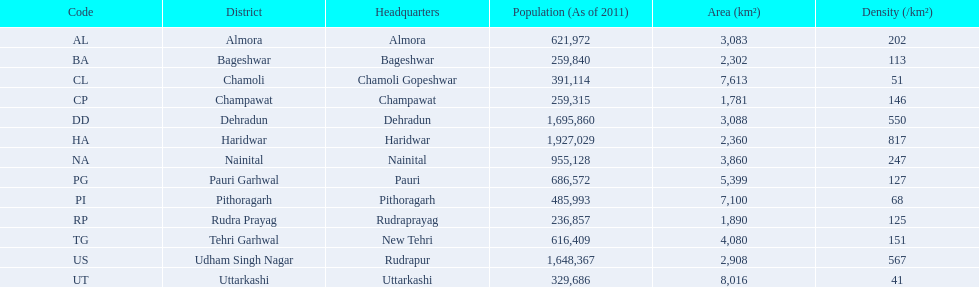What are the titles of all the districts? Almora, Bageshwar, Chamoli, Champawat, Dehradun, Haridwar, Nainital, Pauri Garhwal, Pithoragarh, Rudra Prayag, Tehri Garhwal, Udham Singh Nagar, Uttarkashi. What span of densities do these districts cover? 202, 113, 51, 146, 550, 817, 247, 127, 68, 125, 151, 567, 41. Which district maintains a density of 51? Chamoli. 